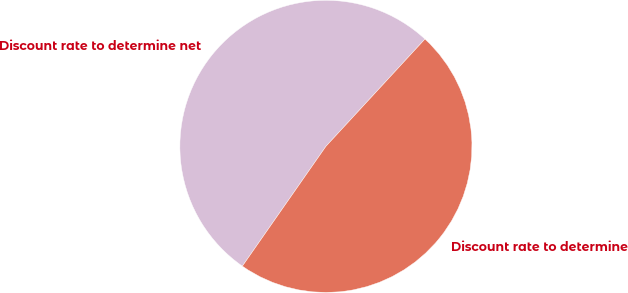Convert chart. <chart><loc_0><loc_0><loc_500><loc_500><pie_chart><fcel>Discount rate to determine net<fcel>Discount rate to determine<nl><fcel>52.17%<fcel>47.83%<nl></chart> 